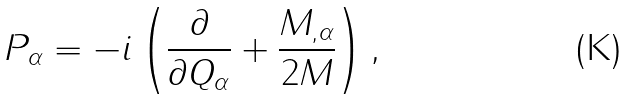<formula> <loc_0><loc_0><loc_500><loc_500>P _ { \alpha } = - i \left ( \frac { \partial } { \partial Q _ { \alpha } } + \frac { M _ { , \alpha } } { 2 M } \right ) ,</formula> 